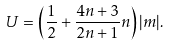Convert formula to latex. <formula><loc_0><loc_0><loc_500><loc_500>U = \left ( \frac { 1 } { 2 } + \frac { 4 n + 3 } { 2 n + 1 } n \right ) | m | .</formula> 